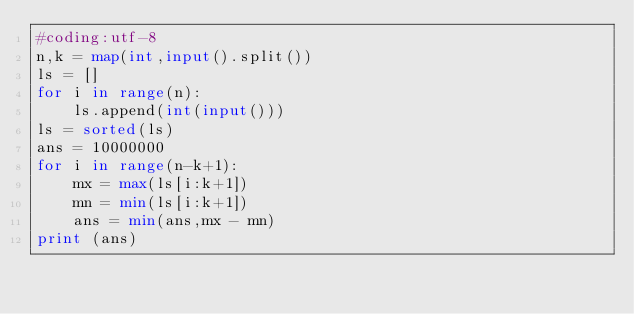Convert code to text. <code><loc_0><loc_0><loc_500><loc_500><_Python_>#coding:utf-8
n,k = map(int,input().split())
ls = []
for i in range(n):
    ls.append(int(input()))
ls = sorted(ls)
ans = 10000000
for i in range(n-k+1):
    mx = max(ls[i:k+1])
    mn = min(ls[i:k+1])
    ans = min(ans,mx - mn)
print (ans)</code> 